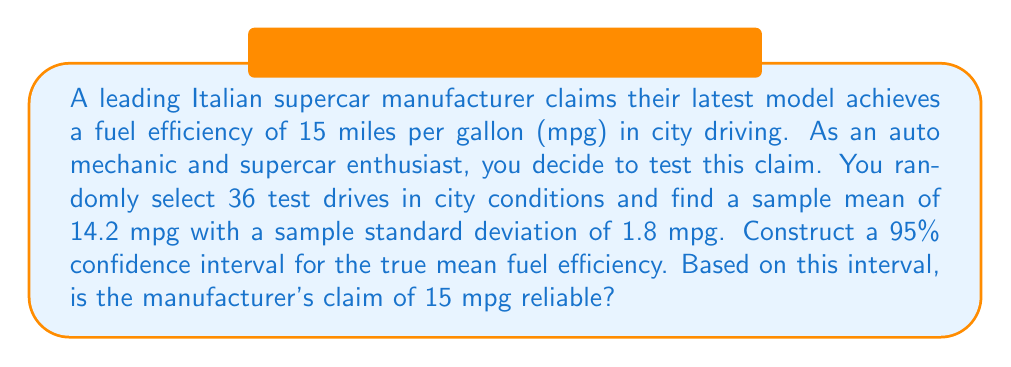Provide a solution to this math problem. Let's approach this step-by-step:

1) We're dealing with a confidence interval for a population mean with unknown population standard deviation. We'll use the t-distribution.

2) Given information:
   - Sample size: $n = 36$
   - Sample mean: $\bar{x} = 14.2$ mpg
   - Sample standard deviation: $s = 1.8$ mpg
   - Confidence level: 95% (α = 0.05)

3) The formula for the confidence interval is:

   $$\bar{x} \pm t_{\frac{\alpha}{2}, n-1} \cdot \frac{s}{\sqrt{n}}$$

4) We need to find the t-value for a 95% confidence interval with 35 degrees of freedom (n-1 = 35).
   From t-distribution table or calculator: $t_{0.025, 35} \approx 2.030$

5) Now, let's calculate the margin of error:

   $$\text{Margin of Error} = t_{\frac{\alpha}{2}, n-1} \cdot \frac{s}{\sqrt{n}} = 2.030 \cdot \frac{1.8}{\sqrt{36}} \approx 0.61$$

6) Therefore, the 95% confidence interval is:

   $$14.2 \pm 0.61$$
   
   $$(13.59, 14.81)$$

7) Interpretation: We are 95% confident that the true mean fuel efficiency is between 13.59 mpg and 14.81 mpg.

8) The manufacturer's claim of 15 mpg is not within this interval, suggesting that their claim may not be reliable based on this sample data.
Answer: (13.59, 14.81) mpg; manufacturer's claim not reliable 